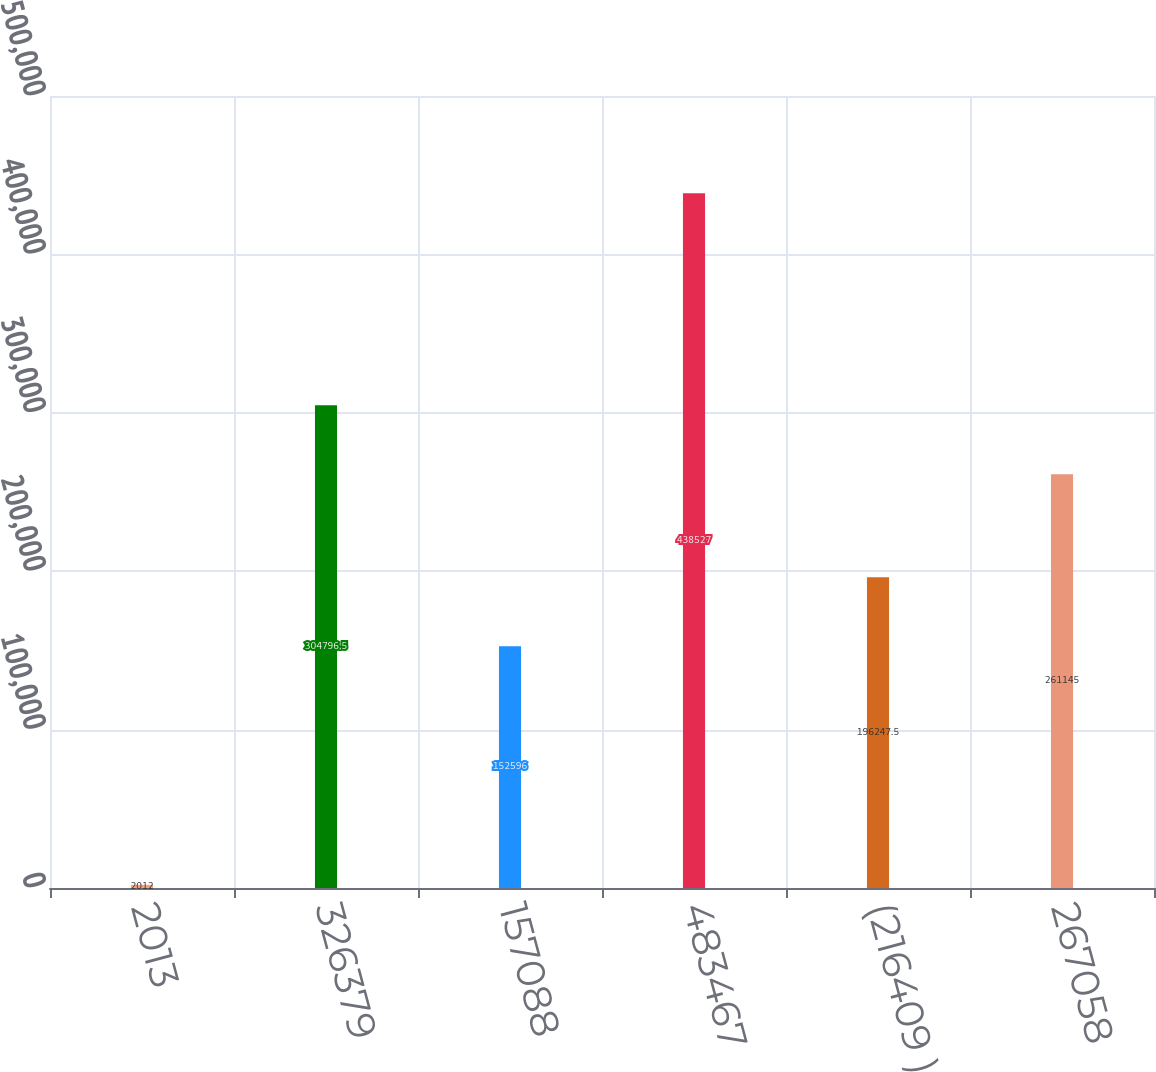Convert chart. <chart><loc_0><loc_0><loc_500><loc_500><bar_chart><fcel>2013<fcel>326379<fcel>157088<fcel>483467<fcel>(216409 )<fcel>267058<nl><fcel>2012<fcel>304796<fcel>152596<fcel>438527<fcel>196248<fcel>261145<nl></chart> 